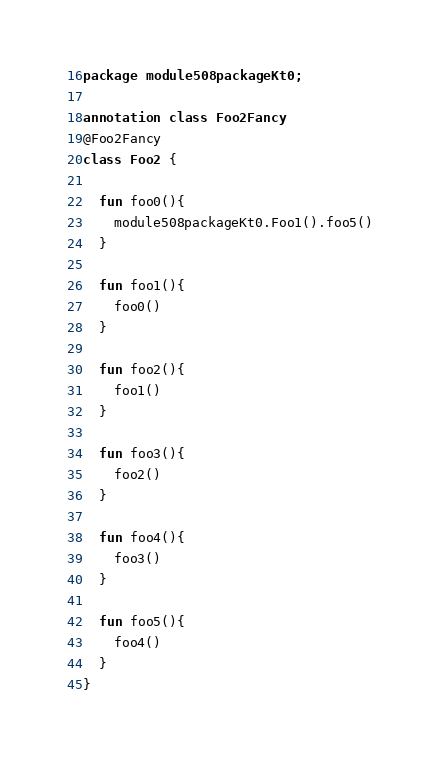<code> <loc_0><loc_0><loc_500><loc_500><_Kotlin_>package module508packageKt0;

annotation class Foo2Fancy
@Foo2Fancy
class Foo2 {

  fun foo0(){
    module508packageKt0.Foo1().foo5()
  }

  fun foo1(){
    foo0()
  }

  fun foo2(){
    foo1()
  }

  fun foo3(){
    foo2()
  }

  fun foo4(){
    foo3()
  }

  fun foo5(){
    foo4()
  }
}</code> 